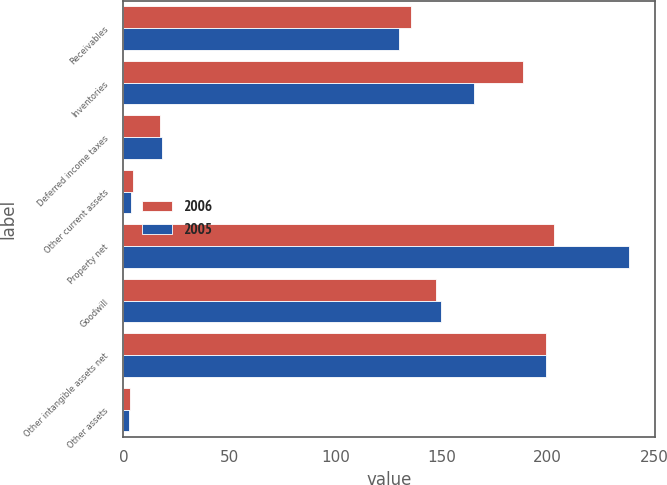<chart> <loc_0><loc_0><loc_500><loc_500><stacked_bar_chart><ecel><fcel>Receivables<fcel>Inventories<fcel>Deferred income taxes<fcel>Other current assets<fcel>Property net<fcel>Goodwill<fcel>Other intangible assets net<fcel>Other assets<nl><fcel>2006<fcel>135.7<fcel>188.1<fcel>17.3<fcel>4.7<fcel>203.1<fcel>147.2<fcel>199<fcel>2.9<nl><fcel>2005<fcel>129.9<fcel>165.1<fcel>18.3<fcel>3.7<fcel>238.5<fcel>149.5<fcel>199.2<fcel>2.4<nl></chart> 